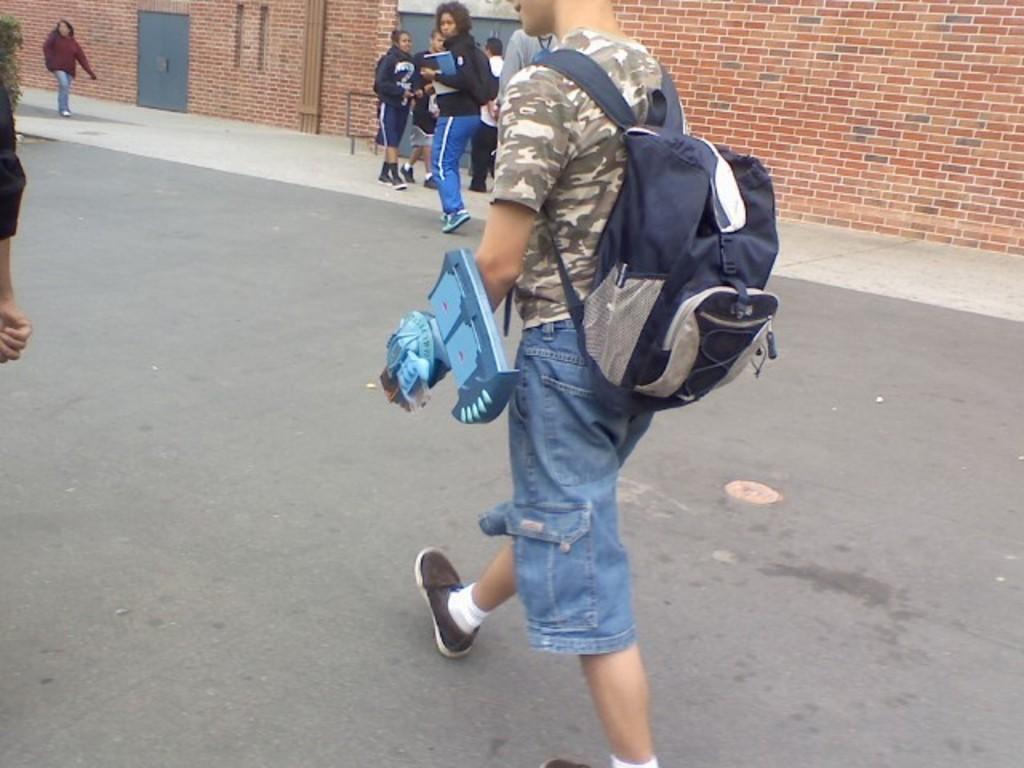Please provide a concise description of this image. In this picture we can see some people where some are walking on road carrying their bags and some are walking on footpath carrying their books and in background we can see wall, pipe, door, tree. 